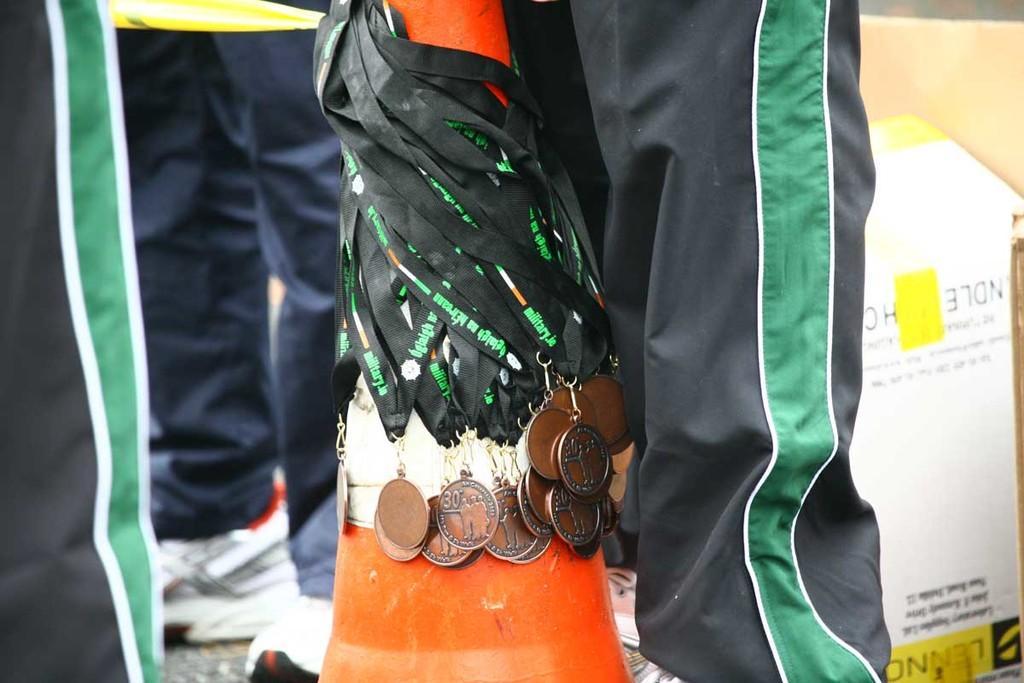Please provide a concise description of this image. In this image we can see some medals, there is a board with some text on it, also we can see legs of people. 